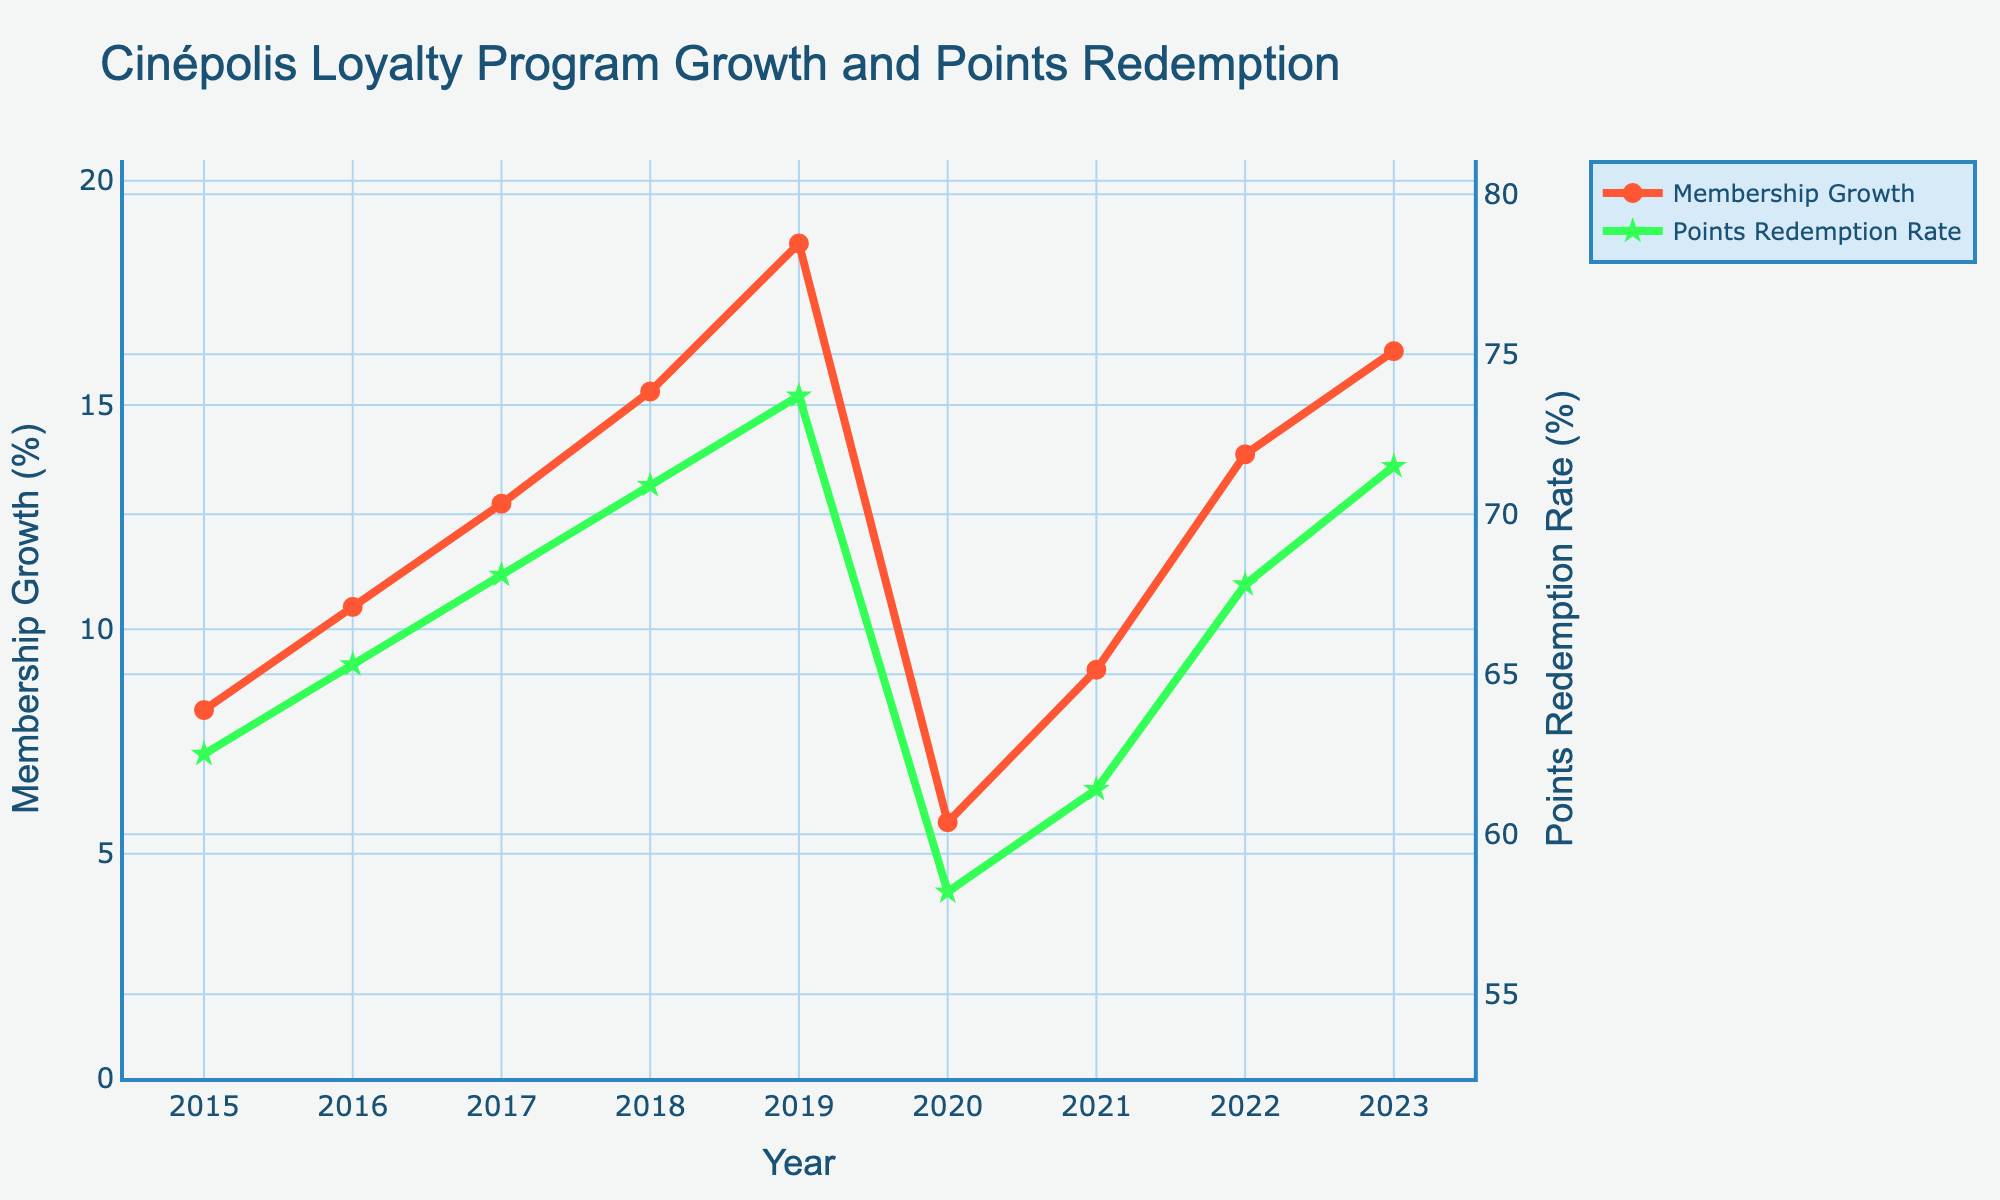What year had the lowest membership growth, and what was the rate? From the chart, we can observe that 2020 had the lowest membership growth. We can read off the corresponding value which is 5.7%.
Answer: 2020, 5.7% Between which years did the points redemption rate decrease, and by how much? From the chart, we can see that the only decrease in points redemption rate occurred between 2019 and 2020. The rate decreased from 73.7% in 2019 to 58.2% in 2020, which is a difference of 73.7% - 58.2% = 15.5%.
Answer: 2019 to 2020, by 15.5% How many years did both membership growth and points redemption rate increase simultaneously? By evaluating each year in the chart, we notice simultaneous increase in 2015, 2016, 2017, 2018, 2019, 2021, 2022, and 2023. There are 8 such years.
Answer: 8 years What was the average membership growth rate over the years 2015 to 2023? To find the average, we sum the membership growth rates from each year (8.2 + 10.5 + 12.8 + 15.3 + 18.6 + 5.7 + 9.1 + 13.9 + 16.2) and divide by the number of years (9). The total sum is 110.3, so the average is 110.3 / 9 ≈ 12.26%.
Answer: 12.26% Compare the membership growth in 2019 to that in 2021. Which year has a higher rate and by how much? From the chart, membership growth in 2019 is 18.6%, and in 2021 it is 9.1%. The membership growth in 2019 is higher by 18.6% - 9.1% = 9.5%.
Answer: 2019, by 9.5% What is the relationship between the membership growth trend and the points redemption rate trend from 2015 to 2023? Visually, the membership growth rate shows a noticeable increasing trend with a notable dip in 2020. Similarly, the points redemption rate generally increases but also dips in 2020. Both trends show recovery after 2020, indicating possible correlation with external events affecting both metrics simultaneously.
Answer: Both trends generally increase, dip in 2020, and recover afterward What was the percentage increase in the membership growth rate from 2020 to 2021? The membership growth rate increased from 5.7% in 2020 to 9.1% in 2021. To find the percentage increase: ((9.1 - 5.7) / 5.7) * 100 = 59.65%.
Answer: 59.65% During which year(s) did the membership growth rate exceed 15%, and what were those rates? From the chart, this occurs in 2018 with 15.3%, 2019 with 18.6%, and 2023 with 16.2%.
Answer: 2018 (15.3%), 2019 (18.6%), 2023 (16.2%) From 2015 to 2019, how much did the points redemption rate increase, and what is the average annual growth rate of redemption during these years? The points redemption rate increased from 62.5% in 2015 to 73.7% in 2019, an increase of 73.7% - 62.5% = 11.2%. The average annual growth rate is found by considering the total increase over the number of periods (4 years), so 11.2% / 4 = 2.8% per year on average.
Answer: Increase by 11.2%, average annual growth rate 2.8% What visual elements in the chart help distinguish between membership growth and points redemption rate? The membership growth line is depicted in red with circular markers, while the points redemption rate is shown in green with star markers. Different y-axes are used for each variable to prevent overlapping. The distinction in color, marker style, and axes aids in visual differentiation.
Answer: Color, marker style, separate y-axes 